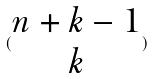<formula> <loc_0><loc_0><loc_500><loc_500>( \begin{matrix} n + k - 1 \\ k \end{matrix} )</formula> 